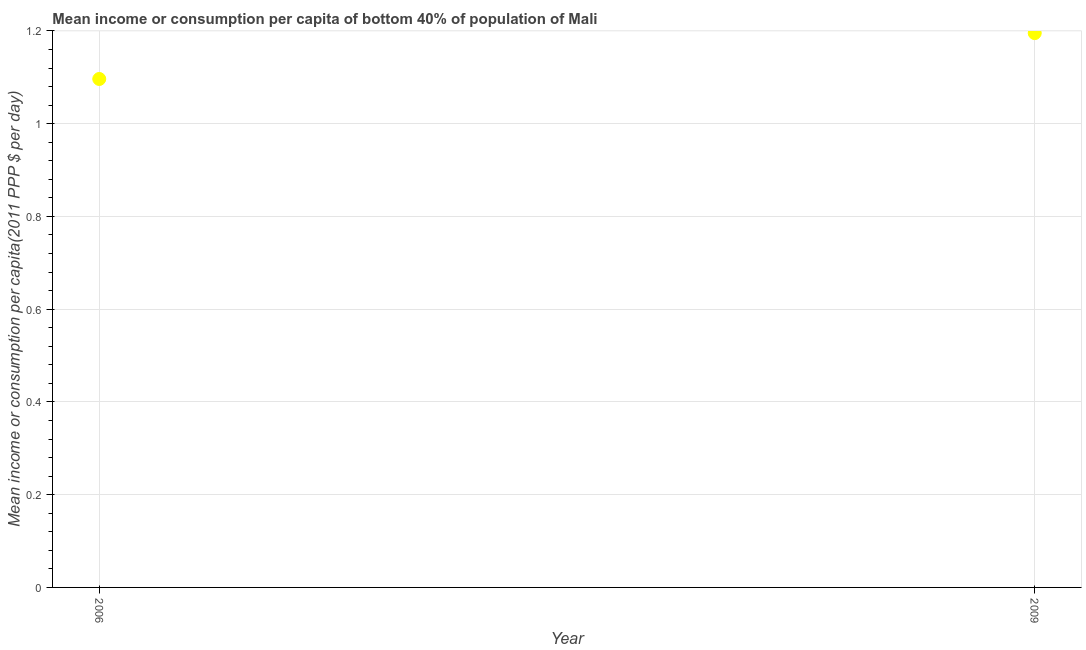What is the mean income or consumption in 2006?
Ensure brevity in your answer.  1.1. Across all years, what is the maximum mean income or consumption?
Make the answer very short. 1.2. Across all years, what is the minimum mean income or consumption?
Ensure brevity in your answer.  1.1. What is the sum of the mean income or consumption?
Give a very brief answer. 2.29. What is the difference between the mean income or consumption in 2006 and 2009?
Your answer should be very brief. -0.1. What is the average mean income or consumption per year?
Provide a succinct answer. 1.15. What is the median mean income or consumption?
Offer a very short reply. 1.15. Do a majority of the years between 2009 and 2006 (inclusive) have mean income or consumption greater than 1 $?
Your response must be concise. No. What is the ratio of the mean income or consumption in 2006 to that in 2009?
Your answer should be very brief. 0.92. How many dotlines are there?
Your answer should be very brief. 1. How many years are there in the graph?
Provide a short and direct response. 2. What is the difference between two consecutive major ticks on the Y-axis?
Your answer should be very brief. 0.2. Are the values on the major ticks of Y-axis written in scientific E-notation?
Provide a succinct answer. No. What is the title of the graph?
Provide a succinct answer. Mean income or consumption per capita of bottom 40% of population of Mali. What is the label or title of the X-axis?
Provide a succinct answer. Year. What is the label or title of the Y-axis?
Give a very brief answer. Mean income or consumption per capita(2011 PPP $ per day). What is the Mean income or consumption per capita(2011 PPP $ per day) in 2006?
Ensure brevity in your answer.  1.1. What is the Mean income or consumption per capita(2011 PPP $ per day) in 2009?
Your response must be concise. 1.2. What is the difference between the Mean income or consumption per capita(2011 PPP $ per day) in 2006 and 2009?
Your response must be concise. -0.1. What is the ratio of the Mean income or consumption per capita(2011 PPP $ per day) in 2006 to that in 2009?
Give a very brief answer. 0.92. 